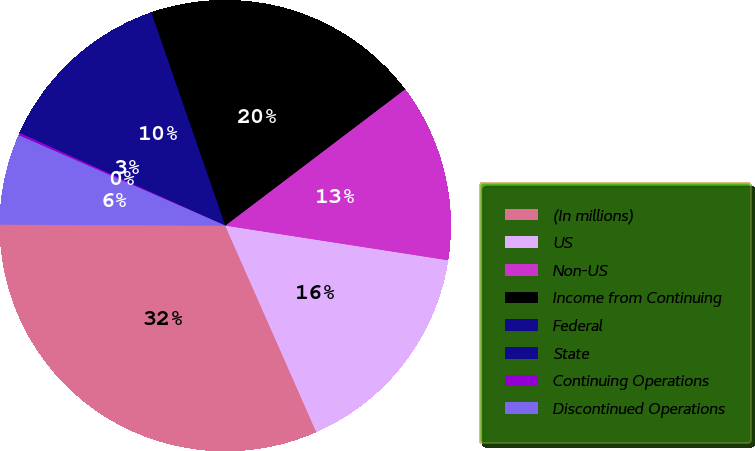Convert chart to OTSL. <chart><loc_0><loc_0><loc_500><loc_500><pie_chart><fcel>(In millions)<fcel>US<fcel>Non-US<fcel>Income from Continuing<fcel>Federal<fcel>State<fcel>Continuing Operations<fcel>Discontinued Operations<nl><fcel>31.69%<fcel>15.93%<fcel>12.78%<fcel>19.99%<fcel>9.63%<fcel>3.32%<fcel>0.17%<fcel>6.48%<nl></chart> 